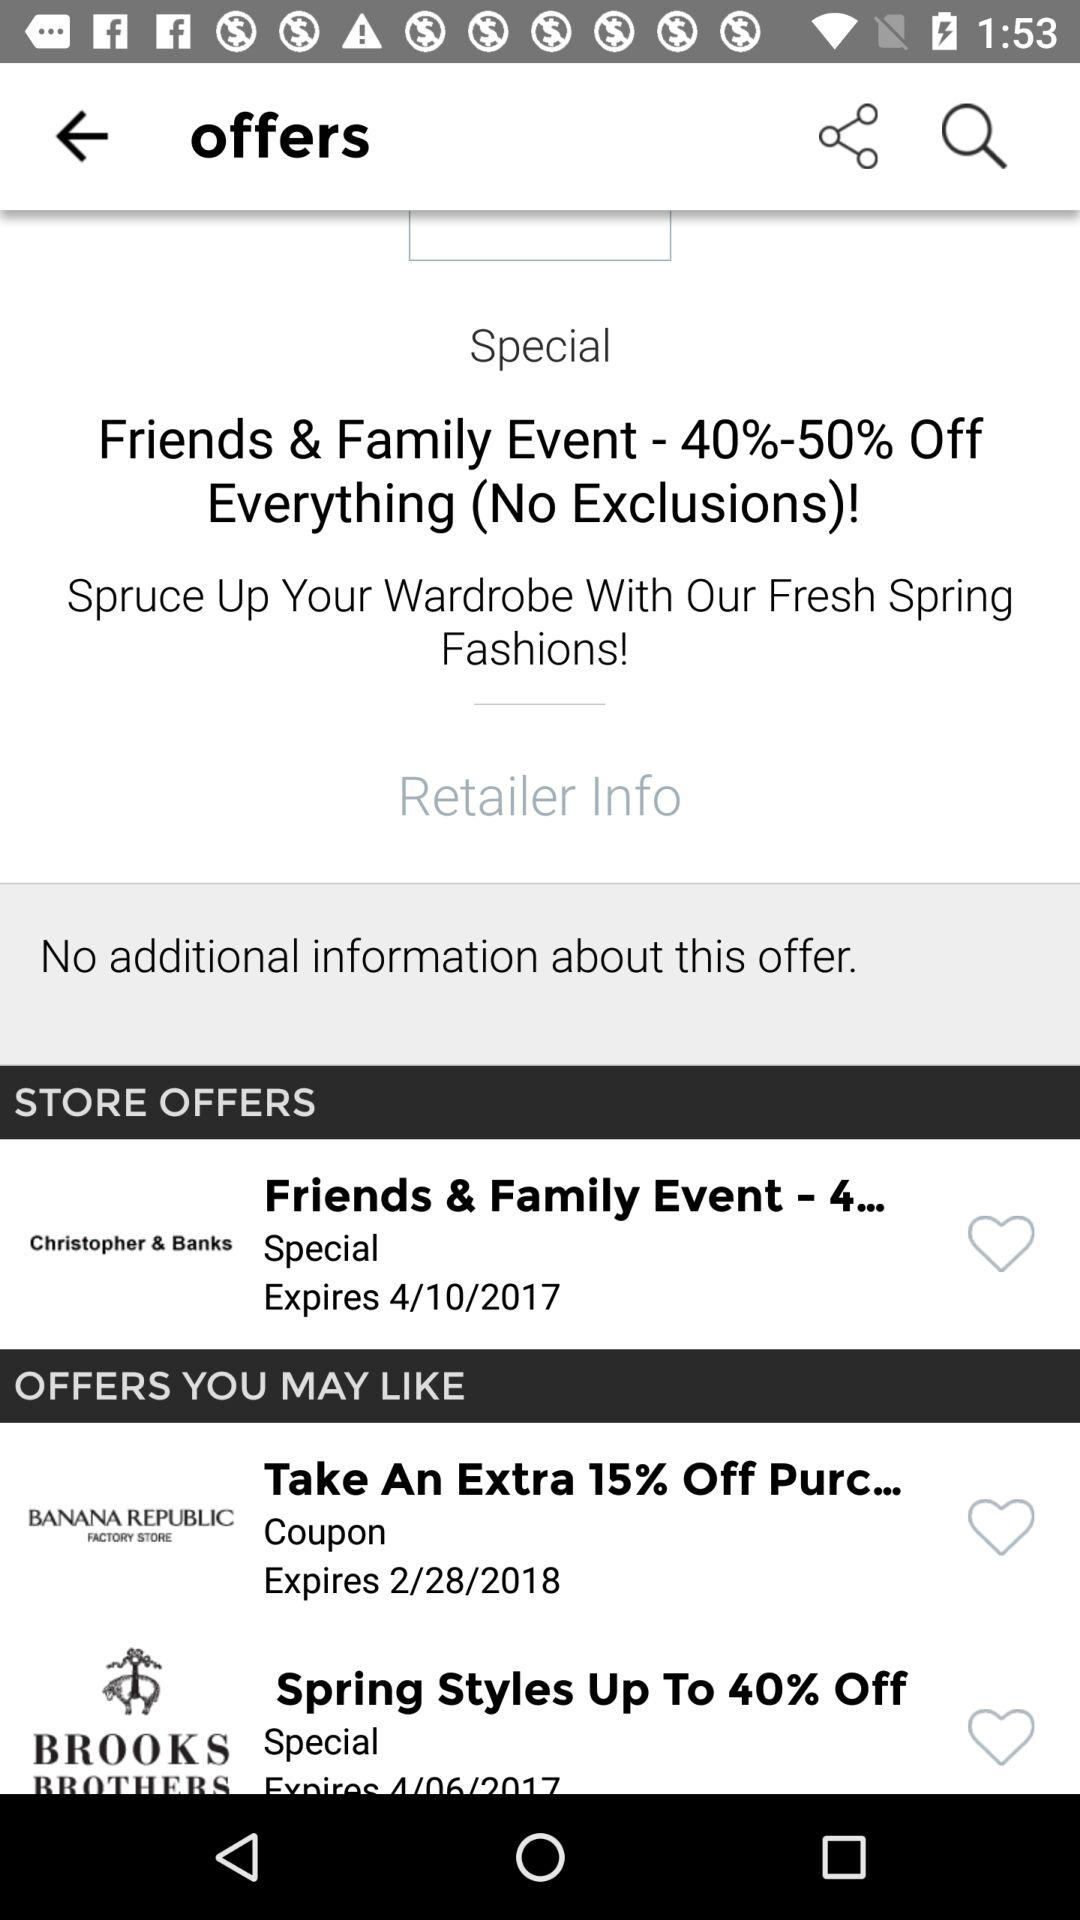What is the expiration date for "Friends & Family Event - 4"? The expiration date is April 10, 2017. 